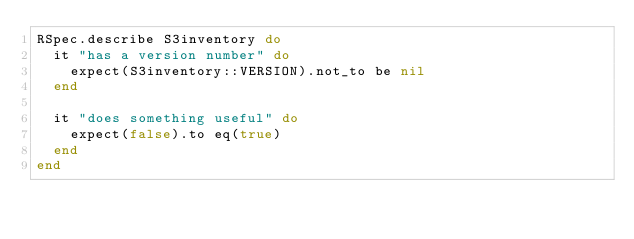Convert code to text. <code><loc_0><loc_0><loc_500><loc_500><_Ruby_>RSpec.describe S3inventory do
  it "has a version number" do
    expect(S3inventory::VERSION).not_to be nil
  end

  it "does something useful" do
    expect(false).to eq(true)
  end
end
</code> 